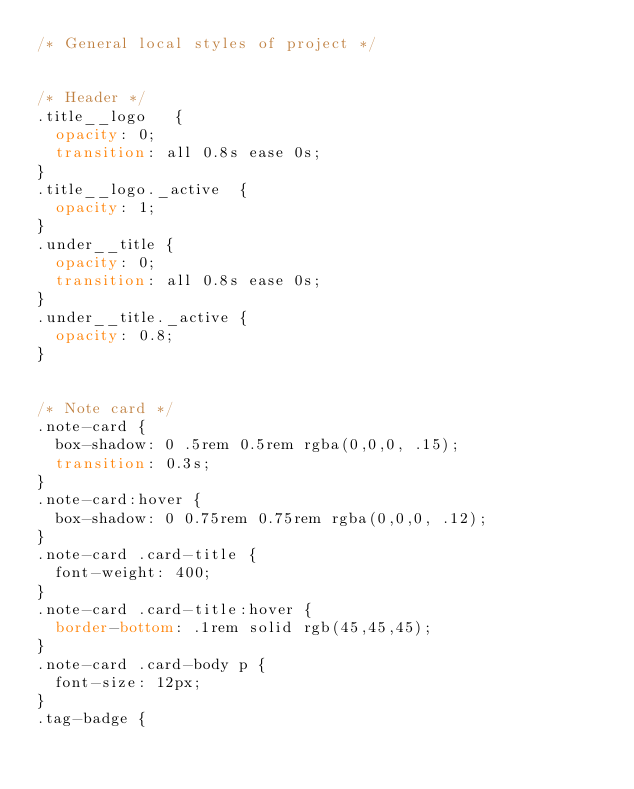Convert code to text. <code><loc_0><loc_0><loc_500><loc_500><_CSS_>/* General local styles of project */


/* Header */
.title__logo   {
	opacity: 0;
	transition: all 0.8s ease 0s;
}
.title__logo._active  {
	opacity: 1;
}
.under__title {
	opacity: 0;
	transition: all 0.8s ease 0s;
}
.under__title._active {
	opacity: 0.8;
}


/* Note card */
.note-card {
	box-shadow: 0 .5rem 0.5rem rgba(0,0,0, .15);
	transition: 0.3s;
}
.note-card:hover {
	box-shadow: 0 0.75rem 0.75rem rgba(0,0,0, .12);
}
.note-card .card-title {
	font-weight: 400;
}
.note-card .card-title:hover {
	border-bottom: .1rem solid rgb(45,45,45);
}
.note-card .card-body p {
	font-size: 12px;
}
.tag-badge {</code> 